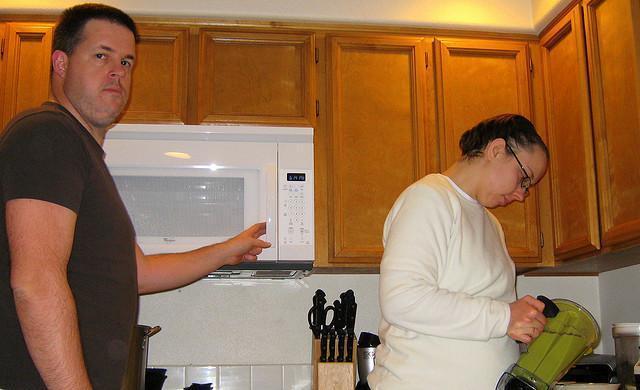How many people can you see?
Give a very brief answer. 2. How many of the airplanes have entrails?
Give a very brief answer. 0. 